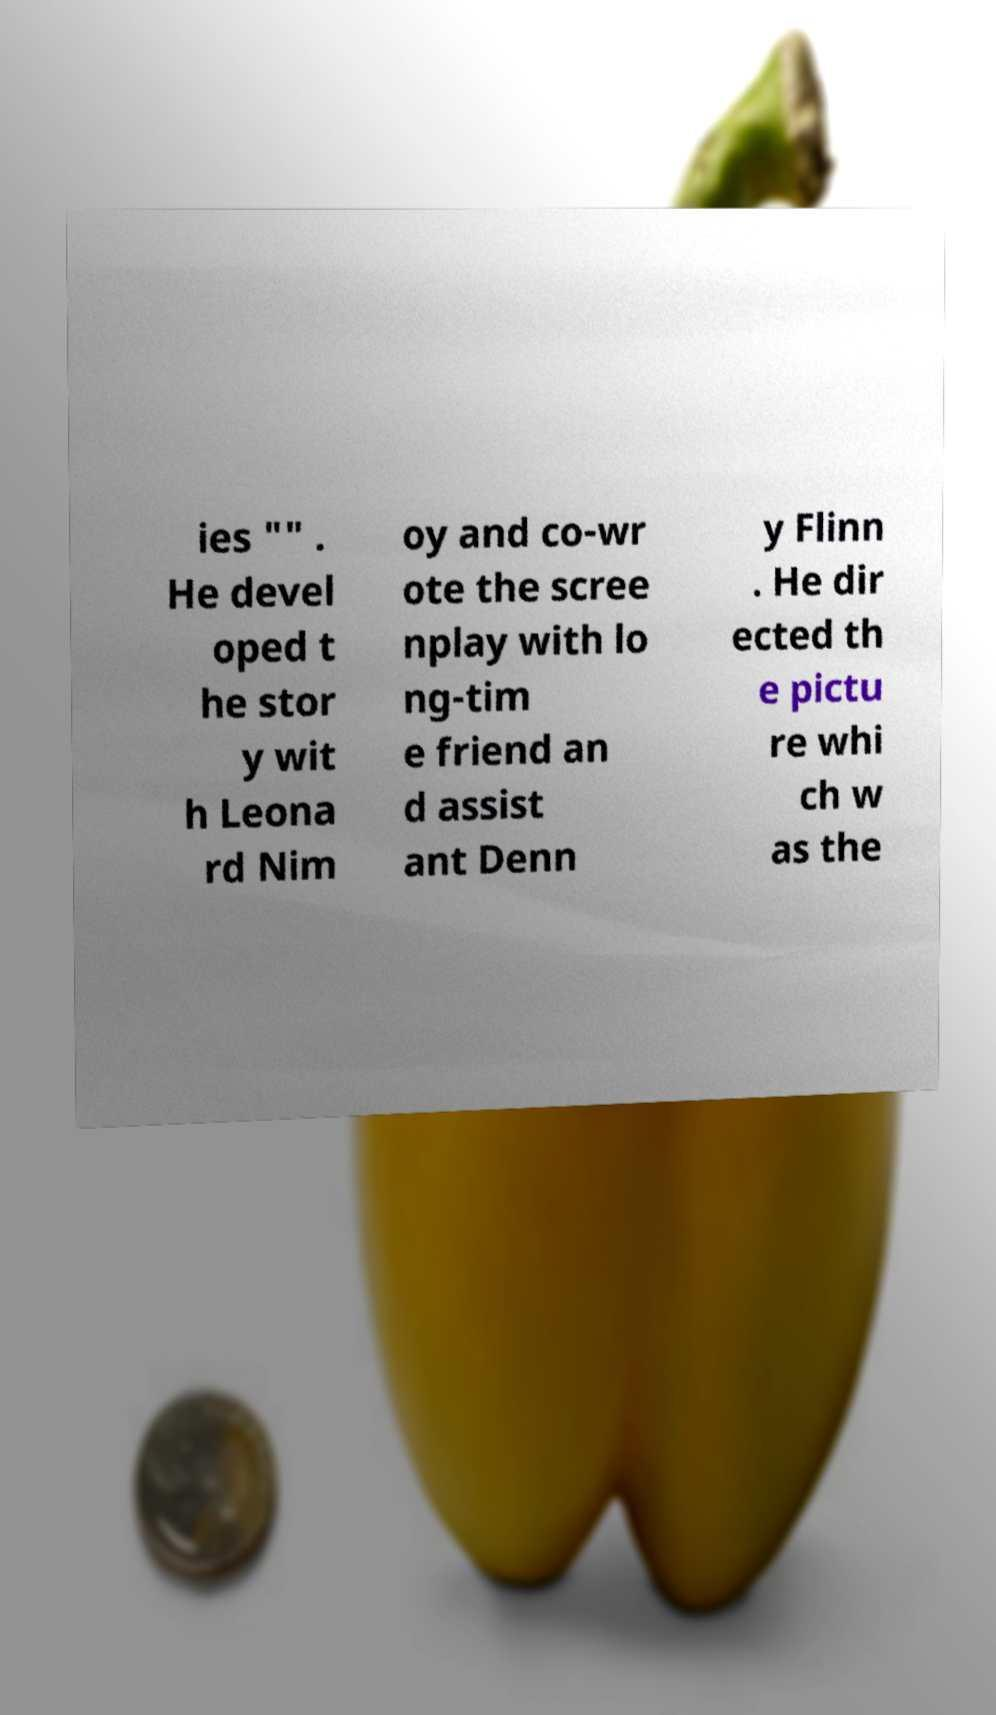I need the written content from this picture converted into text. Can you do that? ies "" . He devel oped t he stor y wit h Leona rd Nim oy and co-wr ote the scree nplay with lo ng-tim e friend an d assist ant Denn y Flinn . He dir ected th e pictu re whi ch w as the 